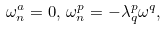<formula> <loc_0><loc_0><loc_500><loc_500>\omega _ { n } ^ { a } = 0 , \, \omega _ { n } ^ { p } = - \lambda _ { q } ^ { p } \omega ^ { q } ,</formula> 